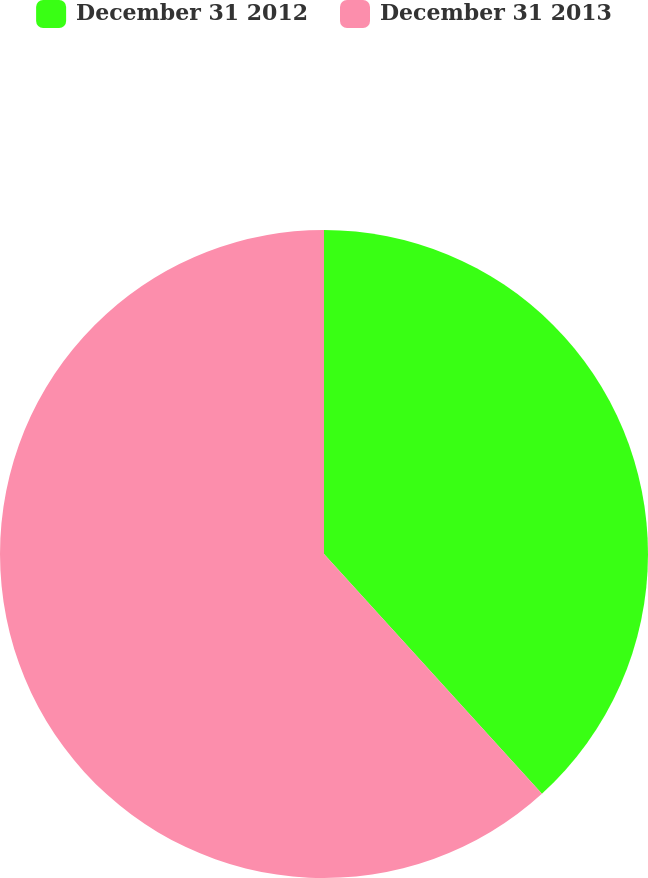Convert chart. <chart><loc_0><loc_0><loc_500><loc_500><pie_chart><fcel>December 31 2012<fcel>December 31 2013<nl><fcel>38.26%<fcel>61.74%<nl></chart> 